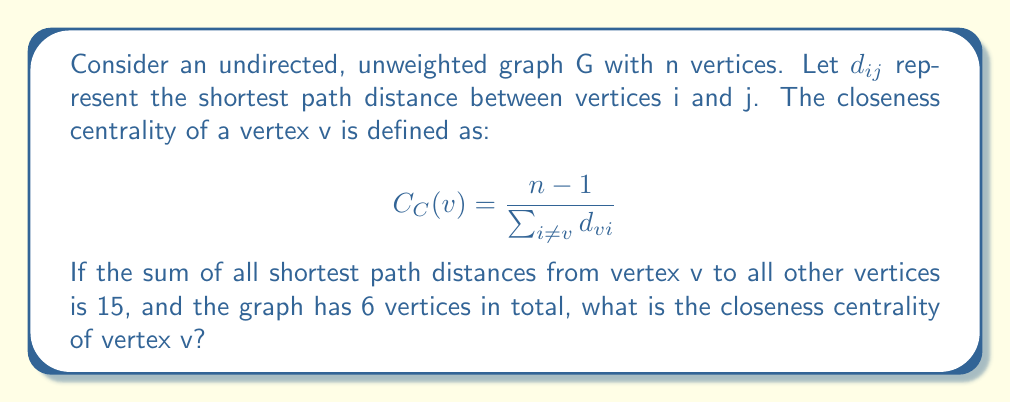Provide a solution to this math problem. To solve this problem, we'll follow these steps:

1. Identify the given information:
   - The graph G has n = 6 vertices
   - The sum of all shortest path distances from v to all other vertices is 15
   - We need to calculate the closeness centrality of vertex v

2. Recall the formula for closeness centrality:
   $$ C_C(v) = \frac{n - 1}{\sum_{i \neq v} d_{vi}} $$

3. Substitute the known values:
   - n = 6
   - $\sum_{i \neq v} d_{vi} = 15$

4. Calculate n - 1:
   n - 1 = 6 - 1 = 5

5. Apply the formula:
   $$ C_C(v) = \frac{5}{15} $$

6. Simplify the fraction:
   $$ C_C(v) = \frac{1}{3} $$

Thus, the closeness centrality of vertex v is 1/3.
Answer: $\frac{1}{3}$ 